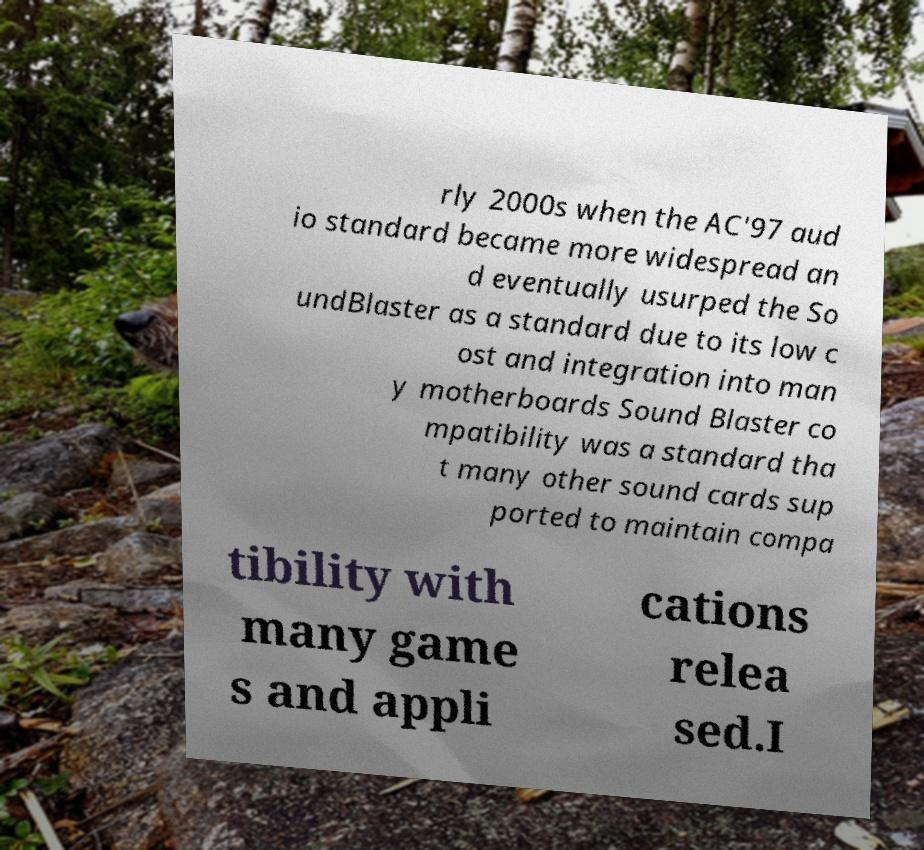There's text embedded in this image that I need extracted. Can you transcribe it verbatim? rly 2000s when the AC'97 aud io standard became more widespread an d eventually usurped the So undBlaster as a standard due to its low c ost and integration into man y motherboards Sound Blaster co mpatibility was a standard tha t many other sound cards sup ported to maintain compa tibility with many game s and appli cations relea sed.I 